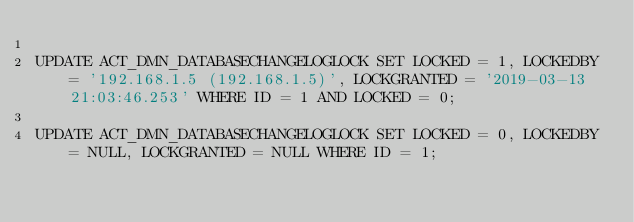Convert code to text. <code><loc_0><loc_0><loc_500><loc_500><_SQL_>
UPDATE ACT_DMN_DATABASECHANGELOGLOCK SET LOCKED = 1, LOCKEDBY = '192.168.1.5 (192.168.1.5)', LOCKGRANTED = '2019-03-13 21:03:46.253' WHERE ID = 1 AND LOCKED = 0;

UPDATE ACT_DMN_DATABASECHANGELOGLOCK SET LOCKED = 0, LOCKEDBY = NULL, LOCKGRANTED = NULL WHERE ID = 1;

</code> 